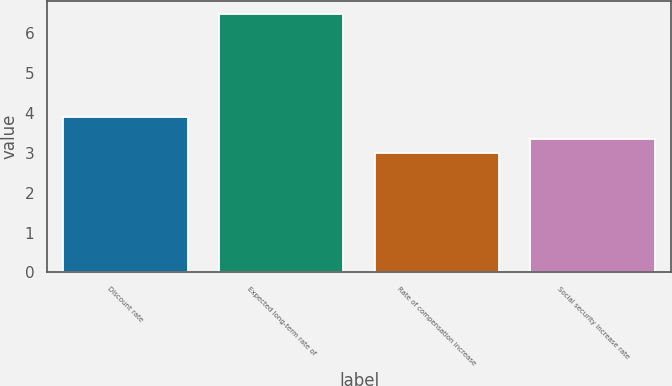Convert chart to OTSL. <chart><loc_0><loc_0><loc_500><loc_500><bar_chart><fcel>Discount rate<fcel>Expected long-term rate of<fcel>Rate of compensation increase<fcel>Social security increase rate<nl><fcel>3.9<fcel>6.5<fcel>3<fcel>3.35<nl></chart> 